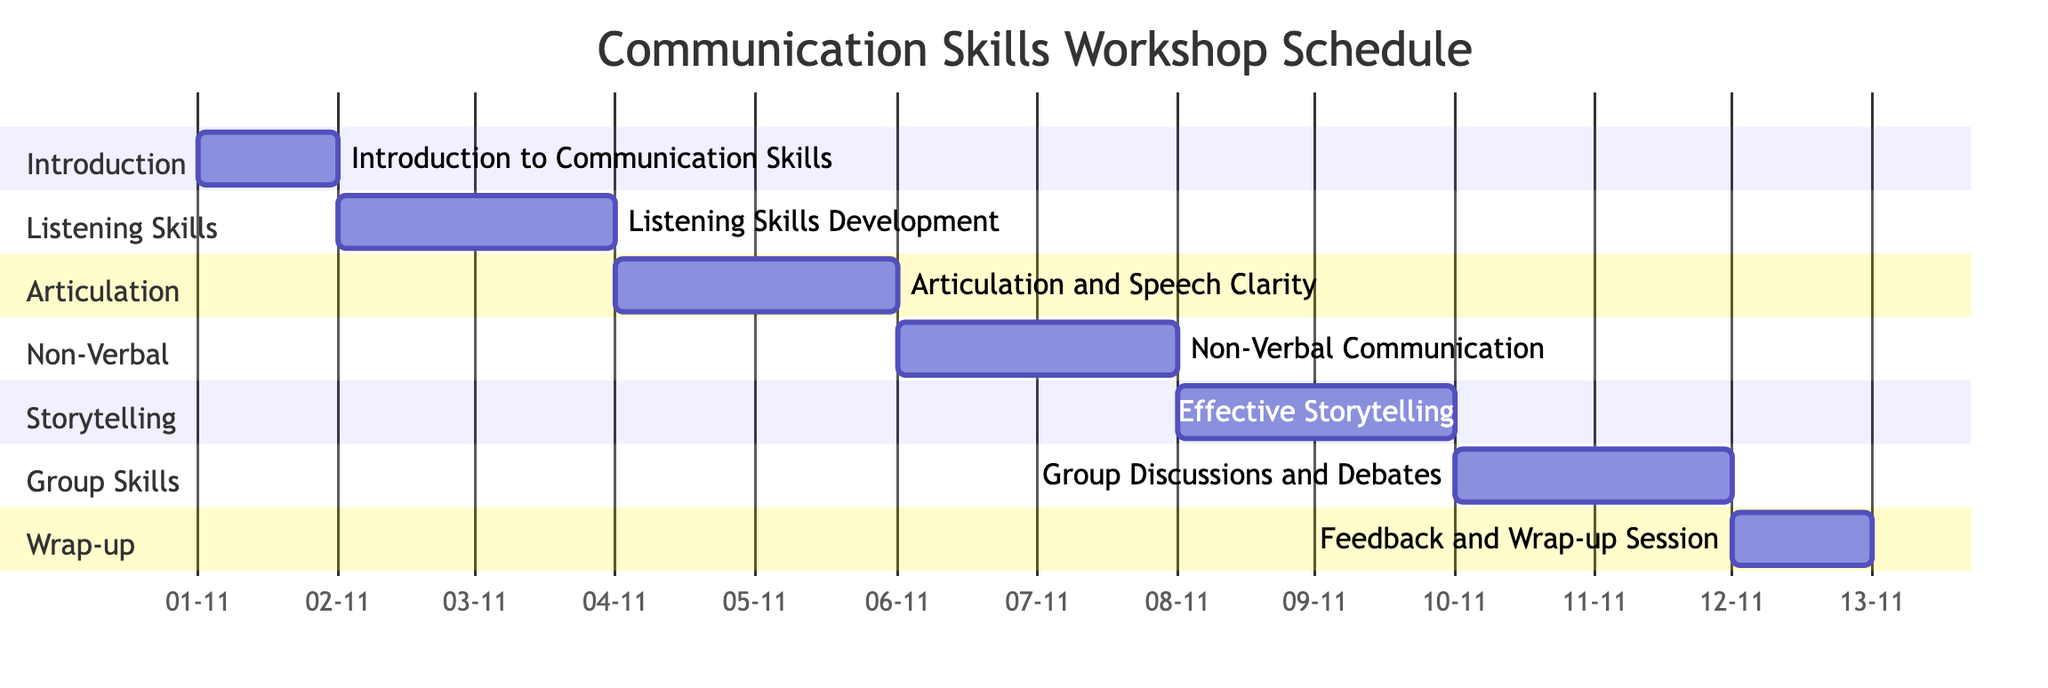What is the duration of the Listening Skills Development session? The Listening Skills Development session starts on November 2, 2023, and ends on November 3, 2023, which is a total of 2 days.
Answer: 2 days How many resources are allocated for the Non-Verbal Communication session? The Non-Verbal Communication session has two resources mentioned: Video Examples and Role-play Scenarios, thus the total is 2 resources.
Answer: 2 resources What is the primary objective of the Effective Storytelling session? The Effective Storytelling session has two objectives, one being "Structuring a Story," which can be considered a primary focus as it relates to the foundational aspect of storytelling.
Answer: Structuring a Story On which date does the Feedback and Wrap-up Session take place? The Feedback and Wrap-up Session is scheduled for November 12, 2023, as indicated by its start and end date being the same.
Answer: November 12, 2023 Which two sessions are scheduled consecutively without any gap? The Articulation and Speech Clarity session ends on November 5, 2023, and the Non-Verbal Communication session starts on November 6, 2023, making them consecutive sessions.
Answer: Articulation and Speech Clarity, Non-Verbal Communication What is the last session in terms of scheduling? By examining the schedule, the last session is the Feedback and Wrap-up Session, which is scheduled for November 12, 2023.
Answer: Feedback and Wrap-up Session How many days are allocated for group discussions? The Group Discussions and Debates session runs for 2 days, starting from November 10, 2023, to November 11, 2023.
Answer: 2 days Which session has the resource of Voice Recorders? The session that has Voice Recorders listed as a resource is the Articulation and Speech Clarity session, which focuses on improving pronunciation.
Answer: Articulation and Speech Clarity What is the start date of the second session? The second session, Listening Skills Development, begins on November 2, 2023, as per the schedule.
Answer: November 2, 2023 